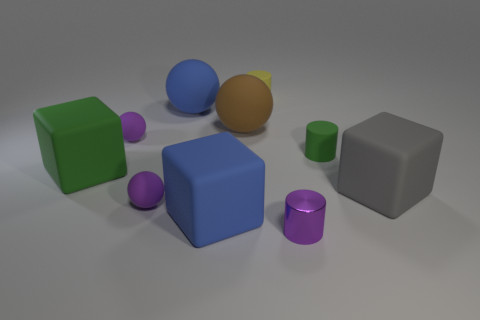Subtract all large gray blocks. How many blocks are left? 2 Subtract all green cylinders. How many cylinders are left? 2 Subtract 1 blue cubes. How many objects are left? 9 Subtract all balls. How many objects are left? 6 Subtract 2 cylinders. How many cylinders are left? 1 Subtract all cyan spheres. Subtract all blue blocks. How many spheres are left? 4 Subtract all purple cubes. How many yellow spheres are left? 0 Subtract all green rubber cylinders. Subtract all large rubber cubes. How many objects are left? 6 Add 9 tiny yellow things. How many tiny yellow things are left? 10 Add 8 brown balls. How many brown balls exist? 9 